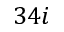<formula> <loc_0><loc_0><loc_500><loc_500>3 4 i</formula> 